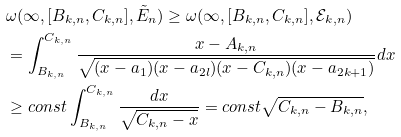<formula> <loc_0><loc_0><loc_500><loc_500>& \omega ( \infty , [ B _ { k , n } , C _ { k , n } ] , \tilde { E } _ { n } ) \geq \omega ( \infty , [ B _ { k , n } , C _ { k , n } ] , { \mathcal { E } } _ { k , n } ) \\ & = \int _ { B _ { k , n } } ^ { C _ { k , n } } \frac { x - A _ { k , n } } { \sqrt { ( x - a _ { 1 } ) ( x - a _ { 2 l } ) ( x - C _ { k , n } ) ( x - a _ { 2 k + 1 } ) } } d x \\ & \geq c o n s t \int _ { B _ { k , n } } ^ { C _ { k , n } } \frac { d x } { \sqrt { C _ { k , n } - x } } = c o n s t \sqrt { C _ { k , n } - B _ { k , n } } ,</formula> 